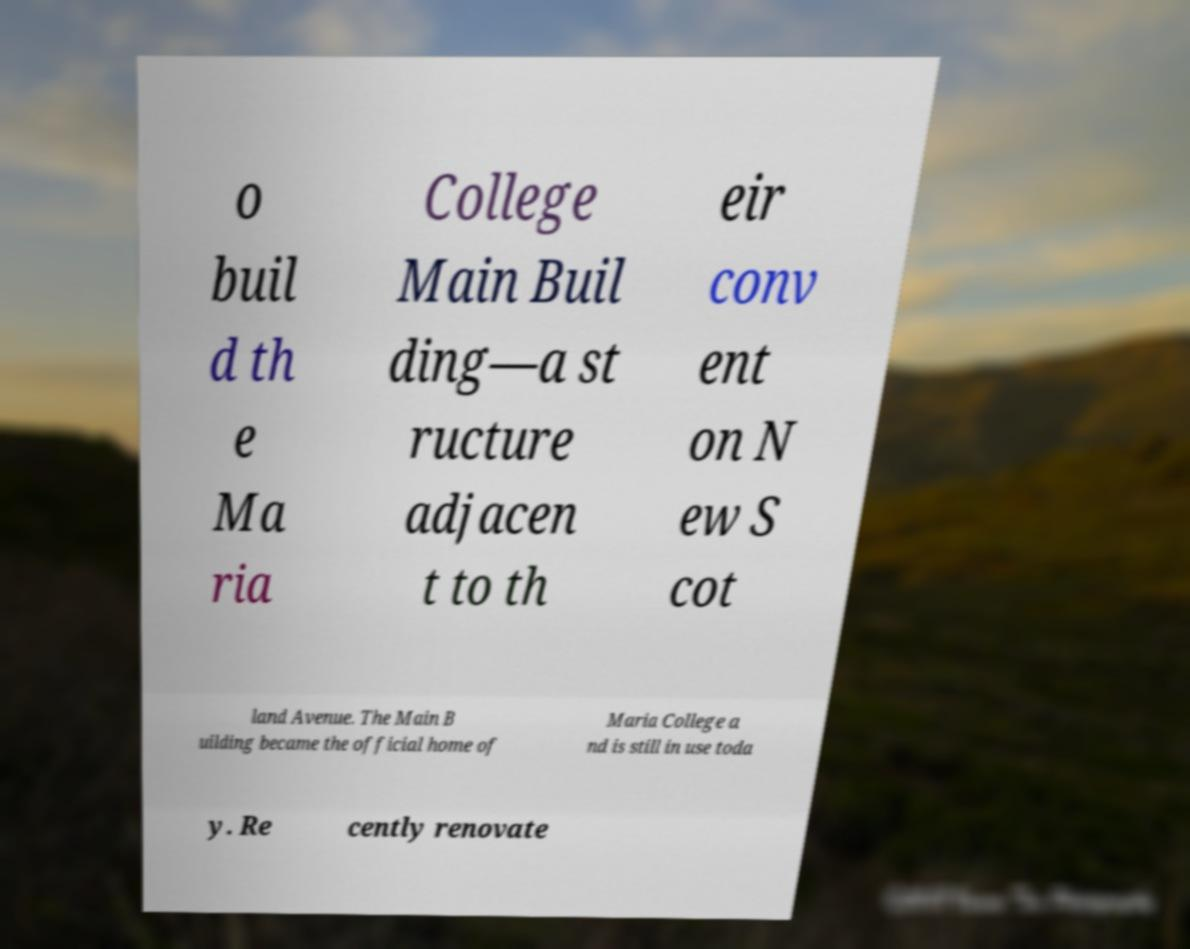I need the written content from this picture converted into text. Can you do that? o buil d th e Ma ria College Main Buil ding—a st ructure adjacen t to th eir conv ent on N ew S cot land Avenue. The Main B uilding became the official home of Maria College a nd is still in use toda y. Re cently renovate 